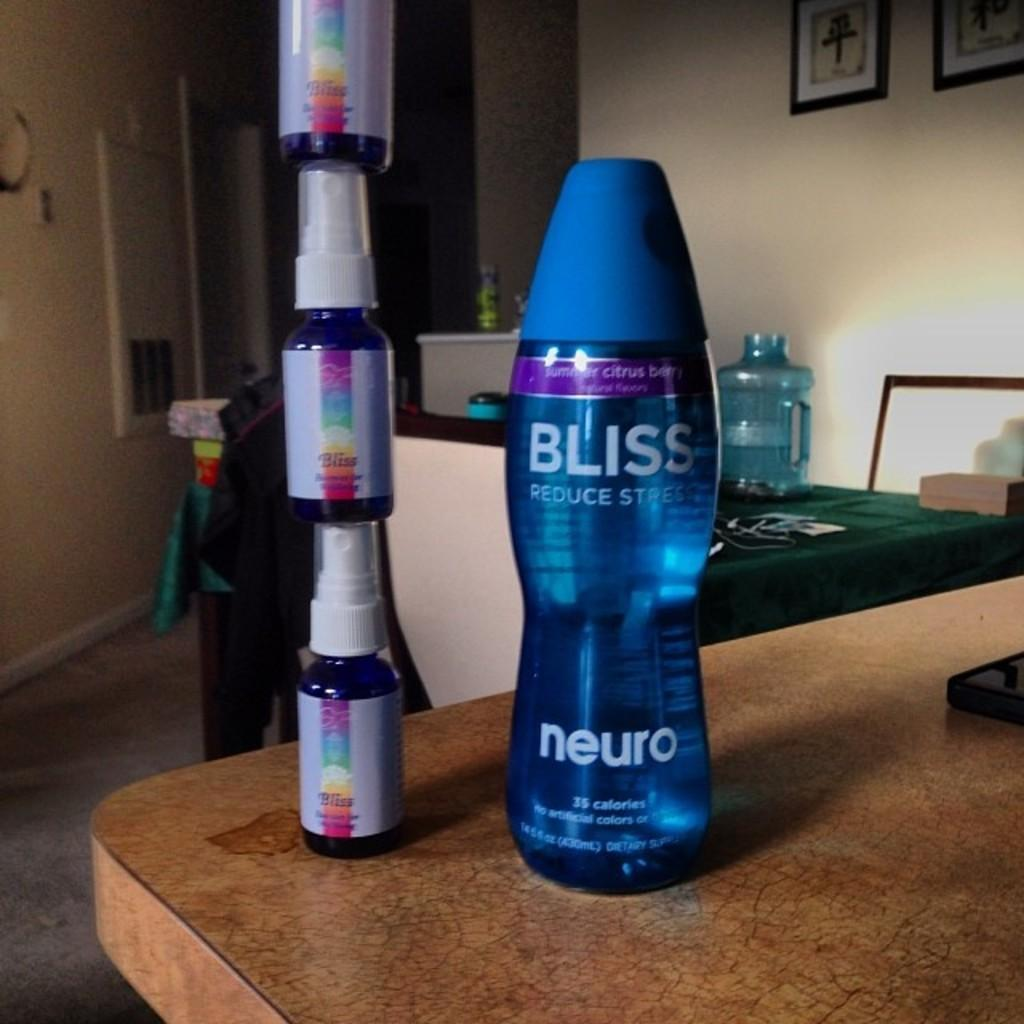<image>
Provide a brief description of the given image. A bottle of Bliss reduce stress next to some spray bottles 